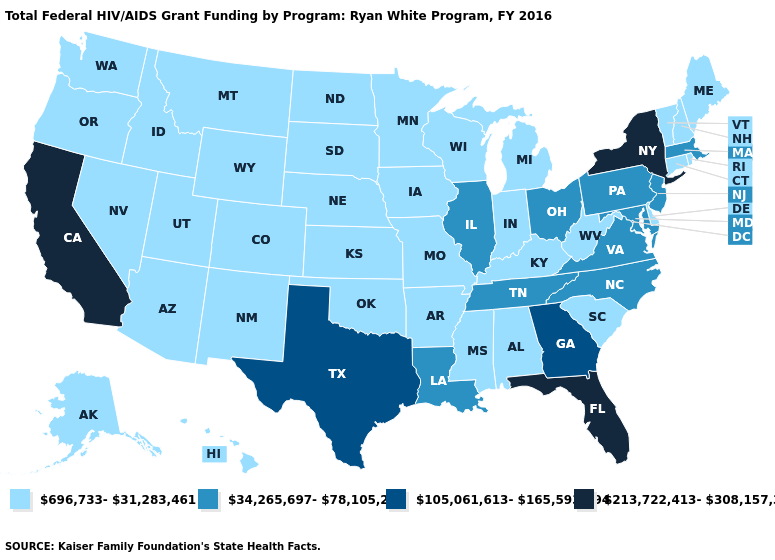Does Oregon have the same value as Indiana?
Give a very brief answer. Yes. Which states have the lowest value in the USA?
Keep it brief. Alabama, Alaska, Arizona, Arkansas, Colorado, Connecticut, Delaware, Hawaii, Idaho, Indiana, Iowa, Kansas, Kentucky, Maine, Michigan, Minnesota, Mississippi, Missouri, Montana, Nebraska, Nevada, New Hampshire, New Mexico, North Dakota, Oklahoma, Oregon, Rhode Island, South Carolina, South Dakota, Utah, Vermont, Washington, West Virginia, Wisconsin, Wyoming. What is the value of Iowa?
Give a very brief answer. 696,733-31,283,461. Does Mississippi have the lowest value in the South?
Short answer required. Yes. Does the map have missing data?
Be succinct. No. What is the value of Oregon?
Be succinct. 696,733-31,283,461. What is the value of Massachusetts?
Keep it brief. 34,265,697-78,105,201. What is the highest value in states that border Maryland?
Short answer required. 34,265,697-78,105,201. What is the value of Utah?
Write a very short answer. 696,733-31,283,461. Does Wisconsin have the same value as Florida?
Write a very short answer. No. Among the states that border New Jersey , which have the lowest value?
Short answer required. Delaware. Among the states that border Mississippi , does Arkansas have the highest value?
Short answer required. No. Name the states that have a value in the range 213,722,413-308,157,325?
Give a very brief answer. California, Florida, New York. Among the states that border Maryland , does Virginia have the lowest value?
Be succinct. No. Does New Hampshire have the highest value in the Northeast?
Write a very short answer. No. 